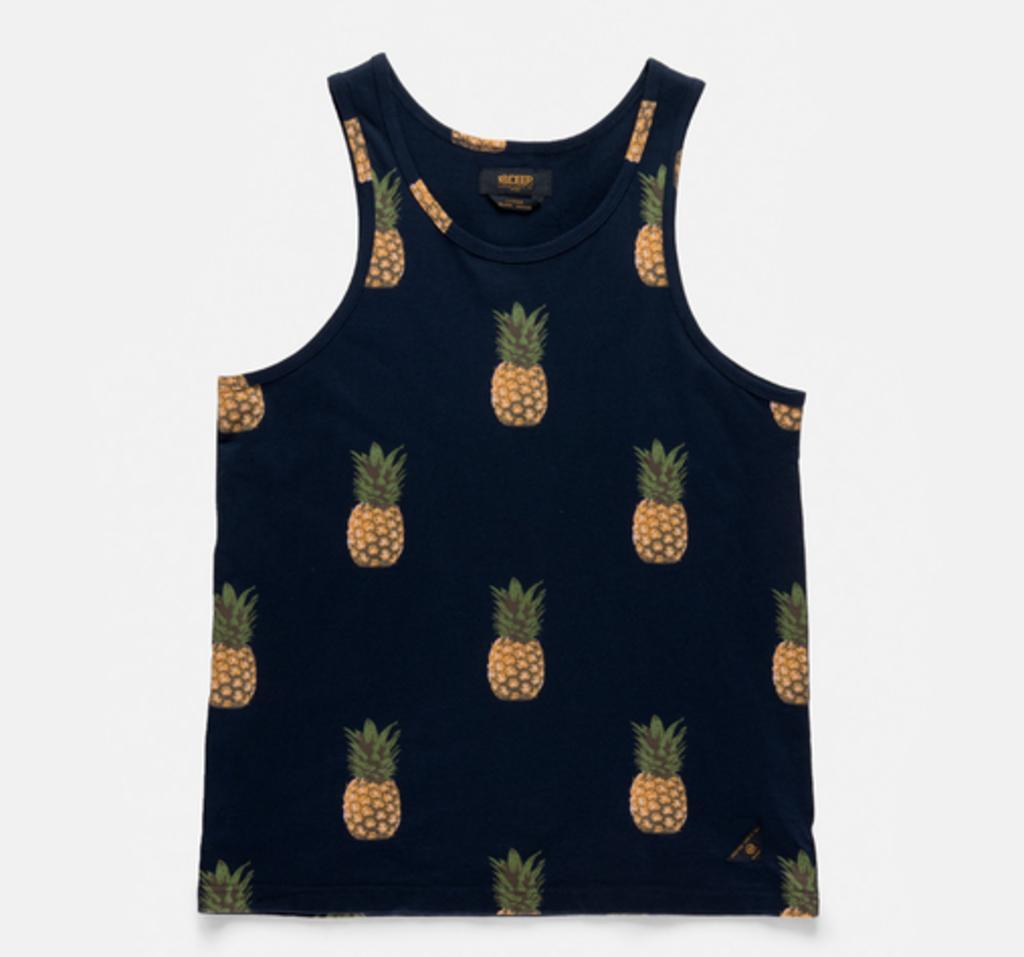Can you describe this image briefly? In the center of the image we can see a tank top with pineapple prints. 